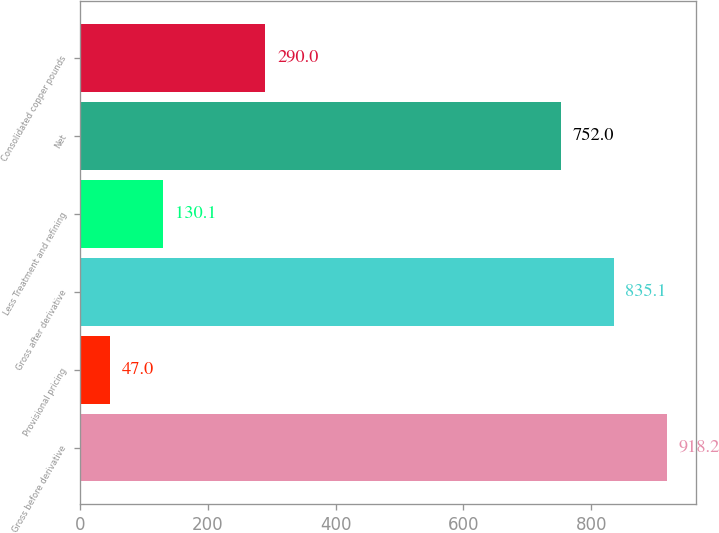Convert chart. <chart><loc_0><loc_0><loc_500><loc_500><bar_chart><fcel>Gross before derivative<fcel>Provisional pricing<fcel>Gross after derivative<fcel>Less Treatment and refining<fcel>Net<fcel>Consolidated copper pounds<nl><fcel>918.2<fcel>47<fcel>835.1<fcel>130.1<fcel>752<fcel>290<nl></chart> 